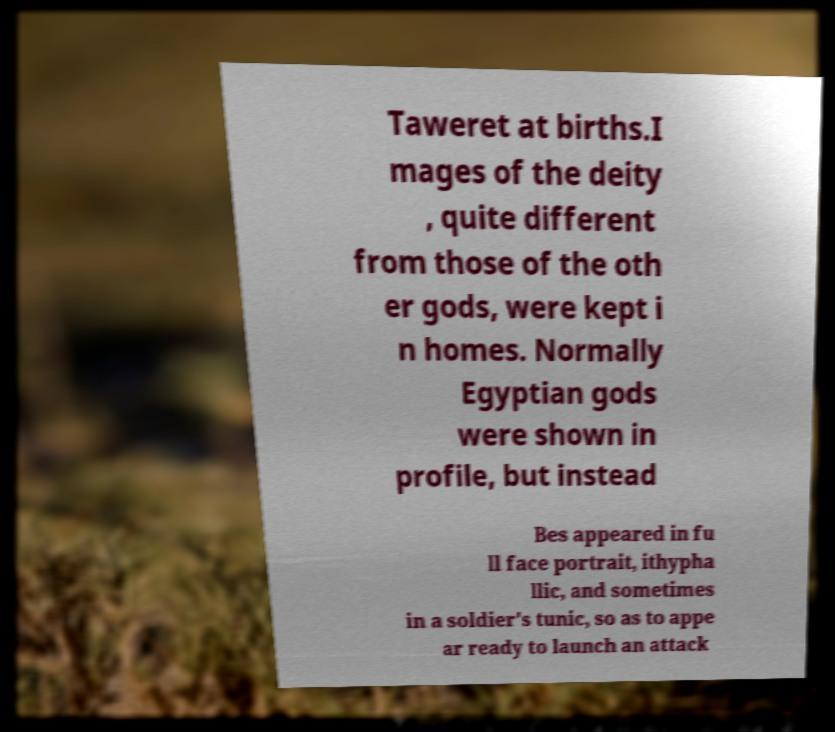There's text embedded in this image that I need extracted. Can you transcribe it verbatim? Taweret at births.I mages of the deity , quite different from those of the oth er gods, were kept i n homes. Normally Egyptian gods were shown in profile, but instead Bes appeared in fu ll face portrait, ithypha llic, and sometimes in a soldier's tunic, so as to appe ar ready to launch an attack 